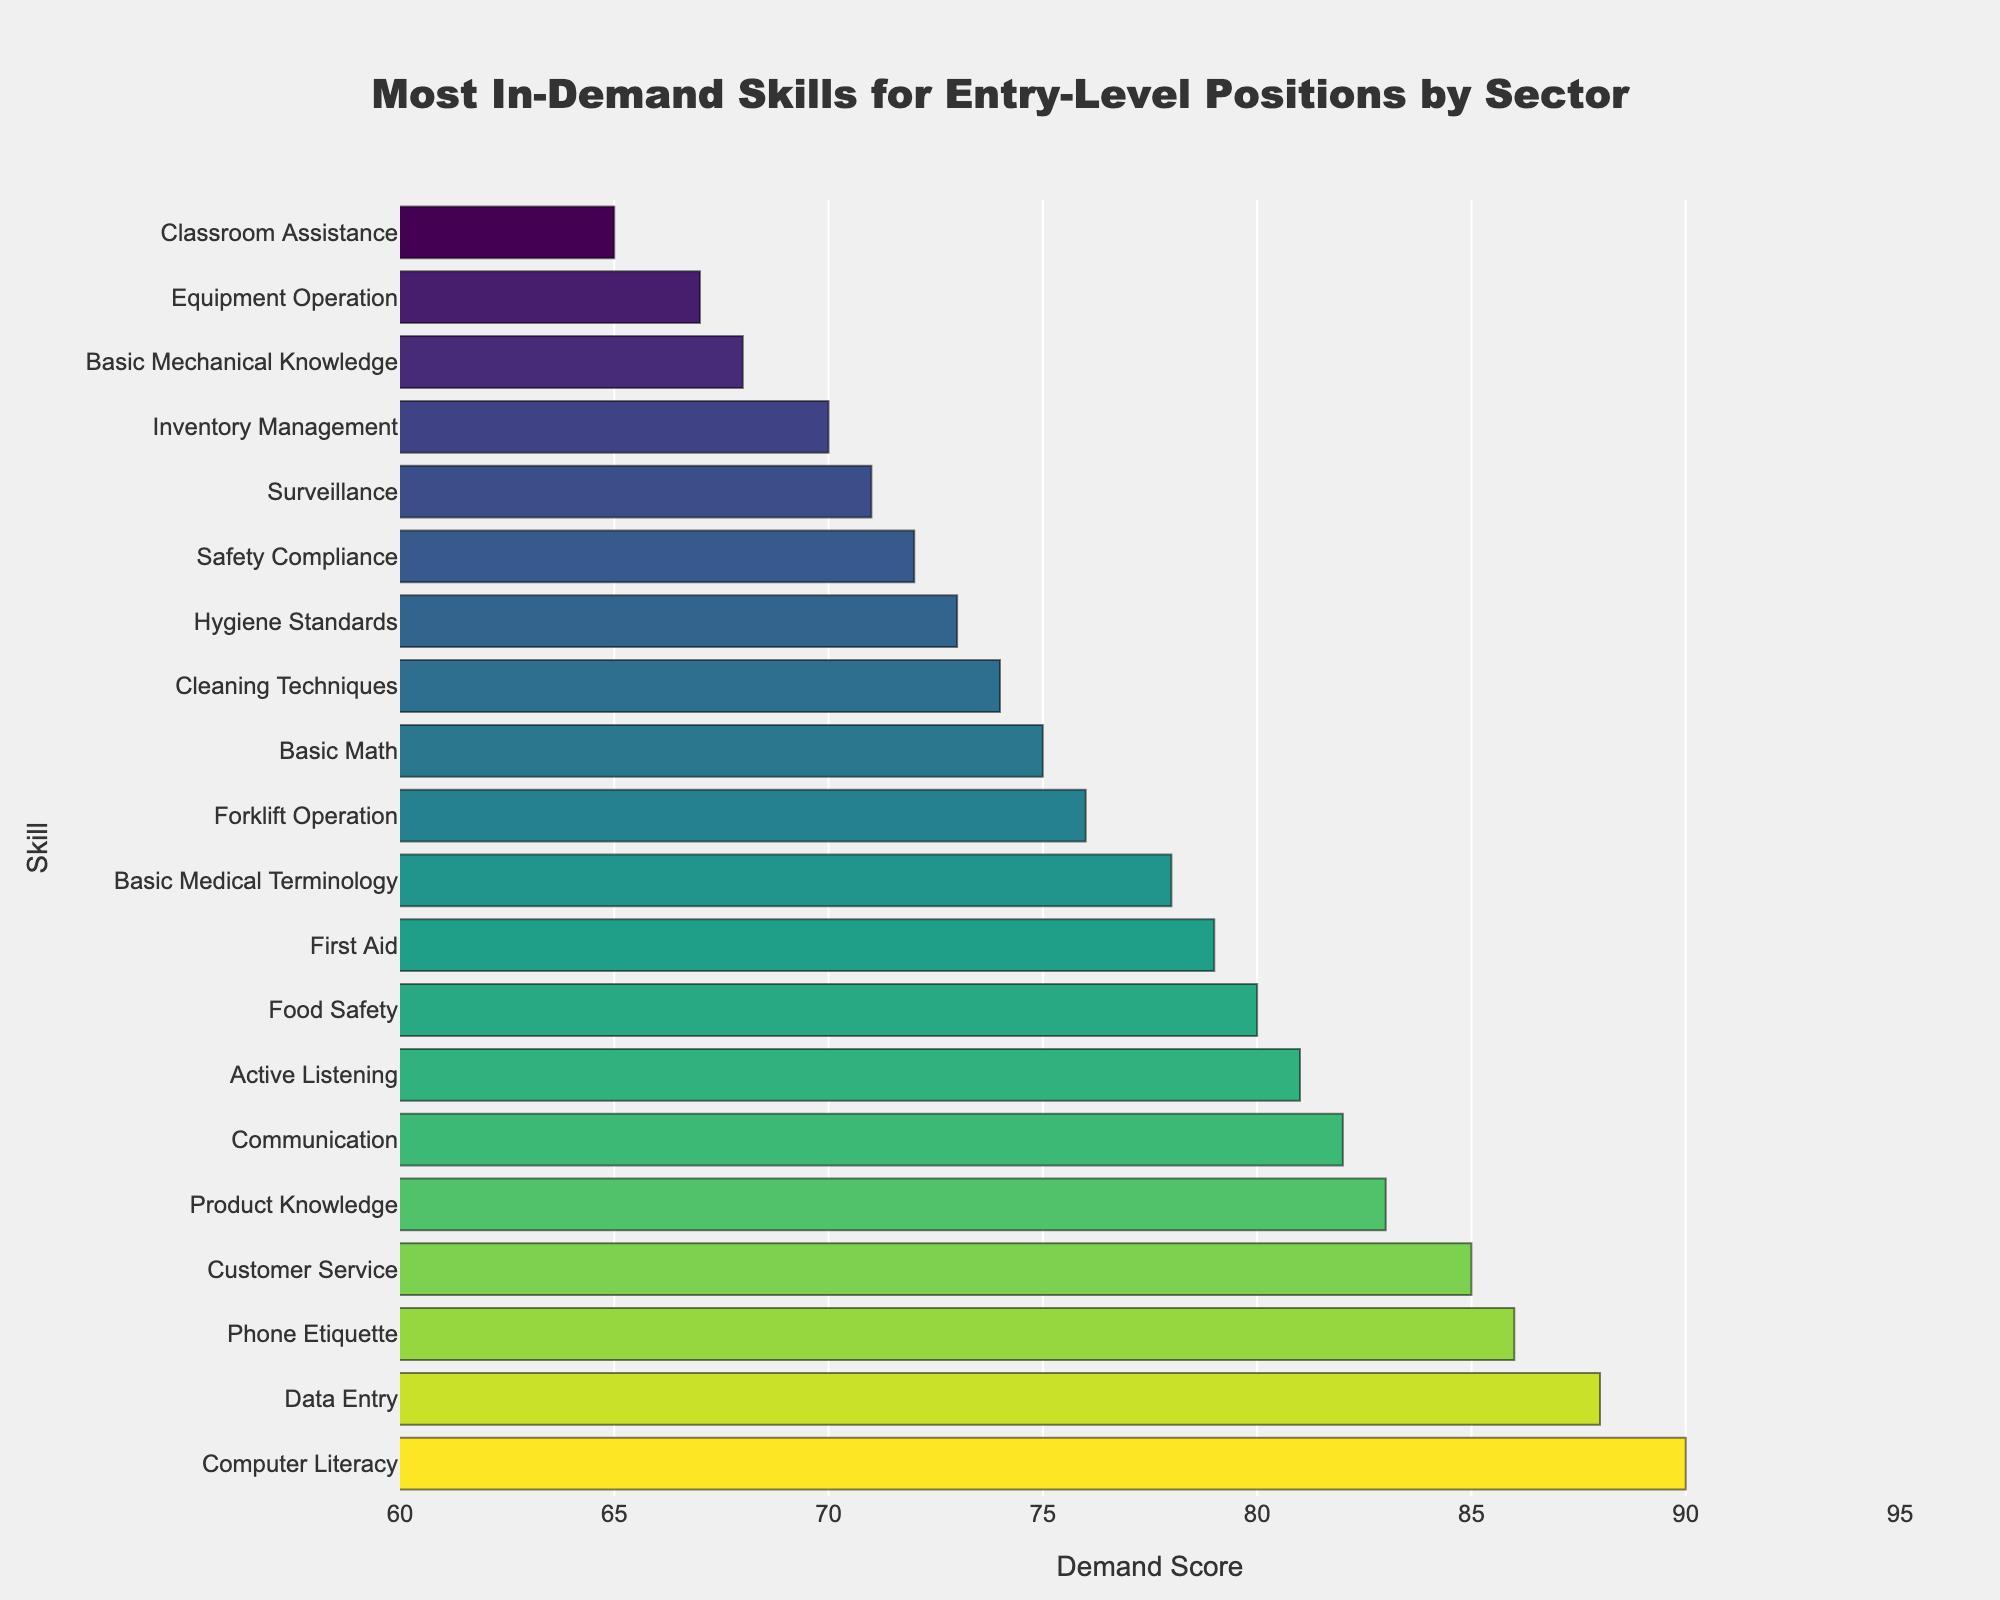What is the most in-demand skill for entry-level positions? The most in-demand skill is the one with the highest demand score. From the figure, the highest demand score is 90 for the skill "Computer Literacy" in the Technology sector.
Answer: Computer Literacy Which skill has a higher demand score: "Customer Service" or "Communication"? Compare the demand scores of both skills. "Customer Service" has a demand score of 85, while "Communication" has a demand score of 82. Therefore, "Customer Service" has a higher demand score.
Answer: Customer Service What is the combined demand score of the top three most in-demand skills? Identify the top three demand scores: 90 (Computer Literacy), 88 (Data Entry), and 86 (Phone Etiquette). Add these scores together: 90 + 88 + 86 = 264.
Answer: 264 Is the demand score for "First Aid" greater than, less than, or equal to "Safety Compliance"? Compare the demand scores of "First Aid" (79) and "Safety Compliance" (72). "First Aid" has a greater score.
Answer: Greater than How does the demand score for "Forklift Operation" compare to that for "Food Safety"? Check the scores for both skills. "Forklift Operation" has a demand score of 76, while "Food Safety" has a demand score of 80. "Forklift Operation" has a lower demand score.
Answer: Lower Which sector requires the skill with the lowest demand score, and what is that skill? Find the skill with the lowest demand score, which is "Classroom Assistance" with a score of 65. The sector for "Classroom Assistance" is Education.
Answer: Education, Classroom Assistance What is the average demand score for skills in the Healthcare, Administrative, and Childcare sectors? Calculate the average of the demand scores for "Basic Medical Terminology" (78), "Data Entry" (88), and "First Aid" (79). Average = (78 + 88 + 79) / 3 = 81.67.
Answer: 81.67 If the demand score for "Product Knowledge" increased by 5 points, what would the new score be? Simply add 5 to the current demand score of "Product Knowledge," which is 83. New score = 83 + 5 = 88.
Answer: 88 Which skill has the same demand score as "Cleaning Techniques," and in which sector is it required? Identify the skill with a score of 74, which matches "Cleaning Techniques." The other skill with a score of 74 is "Hygiene Standards." The sector for "Hygiene Standards" is Beauty and Wellness.
Answer: Hygiene Standards, Beauty and Wellness What is the difference in demand scores between "Inventory Management" and "Surveillance"? Subtract the demand score of "Surveillance" (71) from "Inventory Management" (70). Difference = 70 - 71 = -1.
Answer: -1 